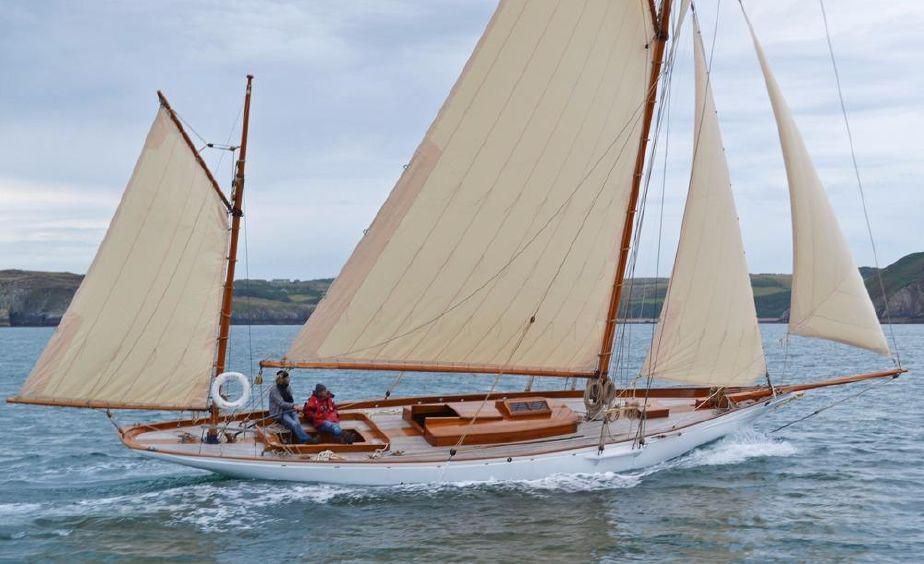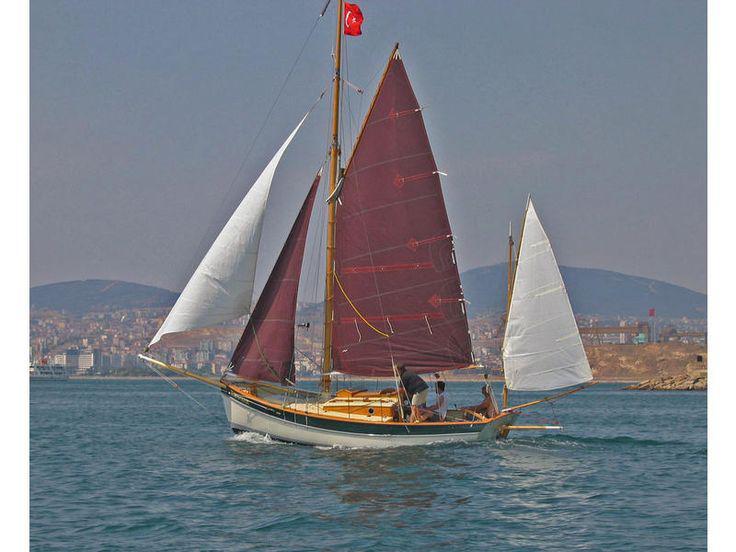The first image is the image on the left, the second image is the image on the right. Analyze the images presented: Is the assertion "There is a sailboat with only two distinct sails." valid? Answer yes or no. No. 